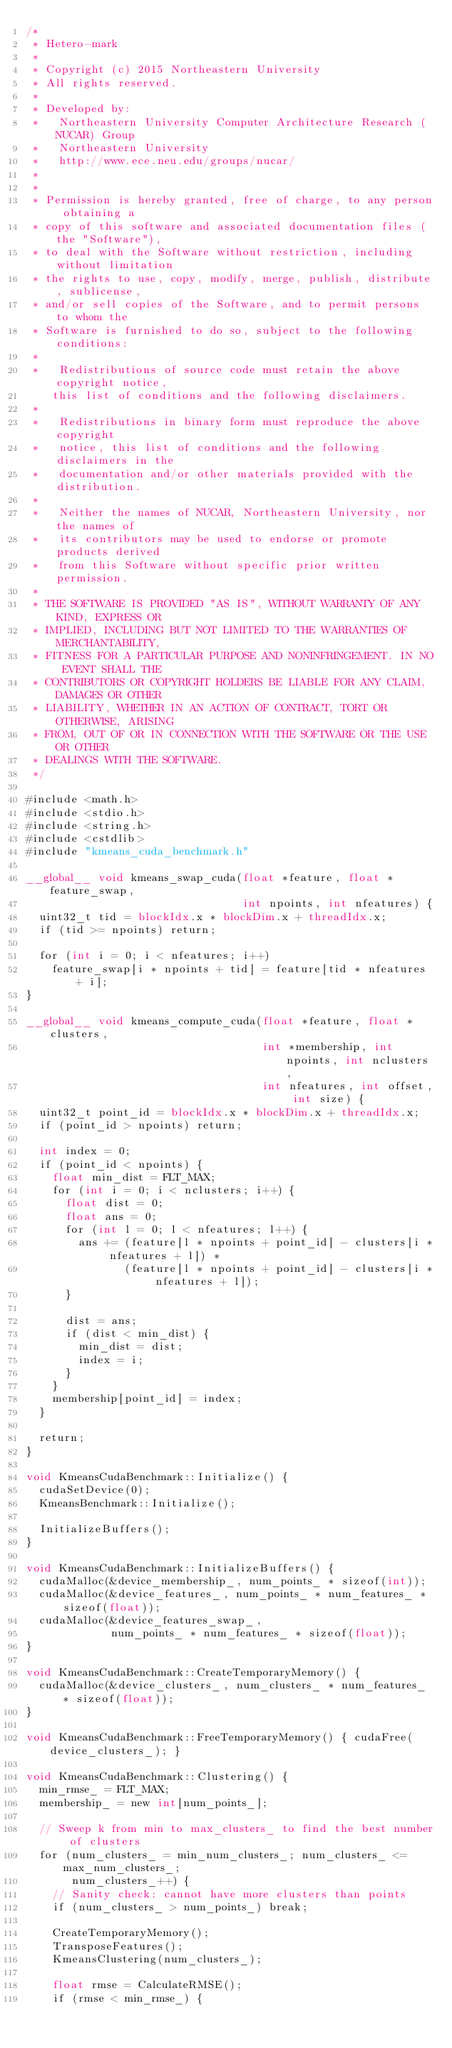Convert code to text. <code><loc_0><loc_0><loc_500><loc_500><_Cuda_>/*
 * Hetero-mark
 *
 * Copyright (c) 2015 Northeastern University
 * All rights reserved.
 *
 * Developed by:
 *   Northeastern University Computer Architecture Research (NUCAR) Group
 *   Northeastern University
 *   http://www.ece.neu.edu/groups/nucar/
 *
 *
 * Permission is hereby granted, free of charge, to any person obtaining a
 * copy of this software and associated documentation files (the "Software"),
 * to deal with the Software without restriction, including without limitation
 * the rights to use, copy, modify, merge, publish, distribute, sublicense,
 * and/or sell copies of the Software, and to permit persons to whom the
 * Software is furnished to do so, subject to the following conditions:
 *
 *   Redistributions of source code must retain the above copyright notice,
    this list of conditions and the following disclaimers.
 *
 *   Redistributions in binary form must reproduce the above copyright
 *   notice, this list of conditions and the following disclaimers in the
 *   documentation and/or other materials provided with the distribution.
 *
 *   Neither the names of NUCAR, Northeastern University, nor the names of
 *   its contributors may be used to endorse or promote products derived
 *   from this Software without specific prior written permission.
 *
 * THE SOFTWARE IS PROVIDED "AS IS", WITHOUT WARRANTY OF ANY KIND, EXPRESS OR
 * IMPLIED, INCLUDING BUT NOT LIMITED TO THE WARRANTIES OF MERCHANTABILITY,
 * FITNESS FOR A PARTICULAR PURPOSE AND NONINFRINGEMENT. IN NO EVENT SHALL THE
 * CONTRIBUTORS OR COPYRIGHT HOLDERS BE LIABLE FOR ANY CLAIM, DAMAGES OR OTHER
 * LIABILITY, WHETHER IN AN ACTION OF CONTRACT, TORT OR OTHERWISE, ARISING
 * FROM, OUT OF OR IN CONNECTION WITH THE SOFTWARE OR THE USE OR OTHER
 * DEALINGS WITH THE SOFTWARE.
 */

#include <math.h>
#include <stdio.h>
#include <string.h>
#include <cstdlib>
#include "kmeans_cuda_benchmark.h"

__global__ void kmeans_swap_cuda(float *feature, float *feature_swap,
                                 int npoints, int nfeatures) {
  uint32_t tid = blockIdx.x * blockDim.x + threadIdx.x;
  if (tid >= npoints) return;

  for (int i = 0; i < nfeatures; i++)
    feature_swap[i * npoints + tid] = feature[tid * nfeatures + i];
}

__global__ void kmeans_compute_cuda(float *feature, float *clusters,
                                    int *membership, int npoints, int nclusters,
                                    int nfeatures, int offset, int size) {
  uint32_t point_id = blockIdx.x * blockDim.x + threadIdx.x;
  if (point_id > npoints) return;

  int index = 0;
  if (point_id < npoints) {
    float min_dist = FLT_MAX;
    for (int i = 0; i < nclusters; i++) {
      float dist = 0;
      float ans = 0;
      for (int l = 0; l < nfeatures; l++) {
        ans += (feature[l * npoints + point_id] - clusters[i * nfeatures + l]) *
               (feature[l * npoints + point_id] - clusters[i * nfeatures + l]);
      }

      dist = ans;
      if (dist < min_dist) {
        min_dist = dist;
        index = i;
      }
    }
    membership[point_id] = index;
  }

  return;
}

void KmeansCudaBenchmark::Initialize() {
  cudaSetDevice(0);
  KmeansBenchmark::Initialize();

  InitializeBuffers();
}

void KmeansCudaBenchmark::InitializeBuffers() {
  cudaMalloc(&device_membership_, num_points_ * sizeof(int));
  cudaMalloc(&device_features_, num_points_ * num_features_ * sizeof(float));
  cudaMalloc(&device_features_swap_,
             num_points_ * num_features_ * sizeof(float));
}

void KmeansCudaBenchmark::CreateTemporaryMemory() {
  cudaMalloc(&device_clusters_, num_clusters_ * num_features_ * sizeof(float));
}

void KmeansCudaBenchmark::FreeTemporaryMemory() { cudaFree(device_clusters_); }

void KmeansCudaBenchmark::Clustering() {
  min_rmse_ = FLT_MAX;
  membership_ = new int[num_points_];

  // Sweep k from min to max_clusters_ to find the best number of clusters
  for (num_clusters_ = min_num_clusters_; num_clusters_ <= max_num_clusters_;
       num_clusters_++) {
    // Sanity check: cannot have more clusters than points
    if (num_clusters_ > num_points_) break;

    CreateTemporaryMemory();
    TransposeFeatures();
    KmeansClustering(num_clusters_);

    float rmse = CalculateRMSE();
    if (rmse < min_rmse_) {</code> 